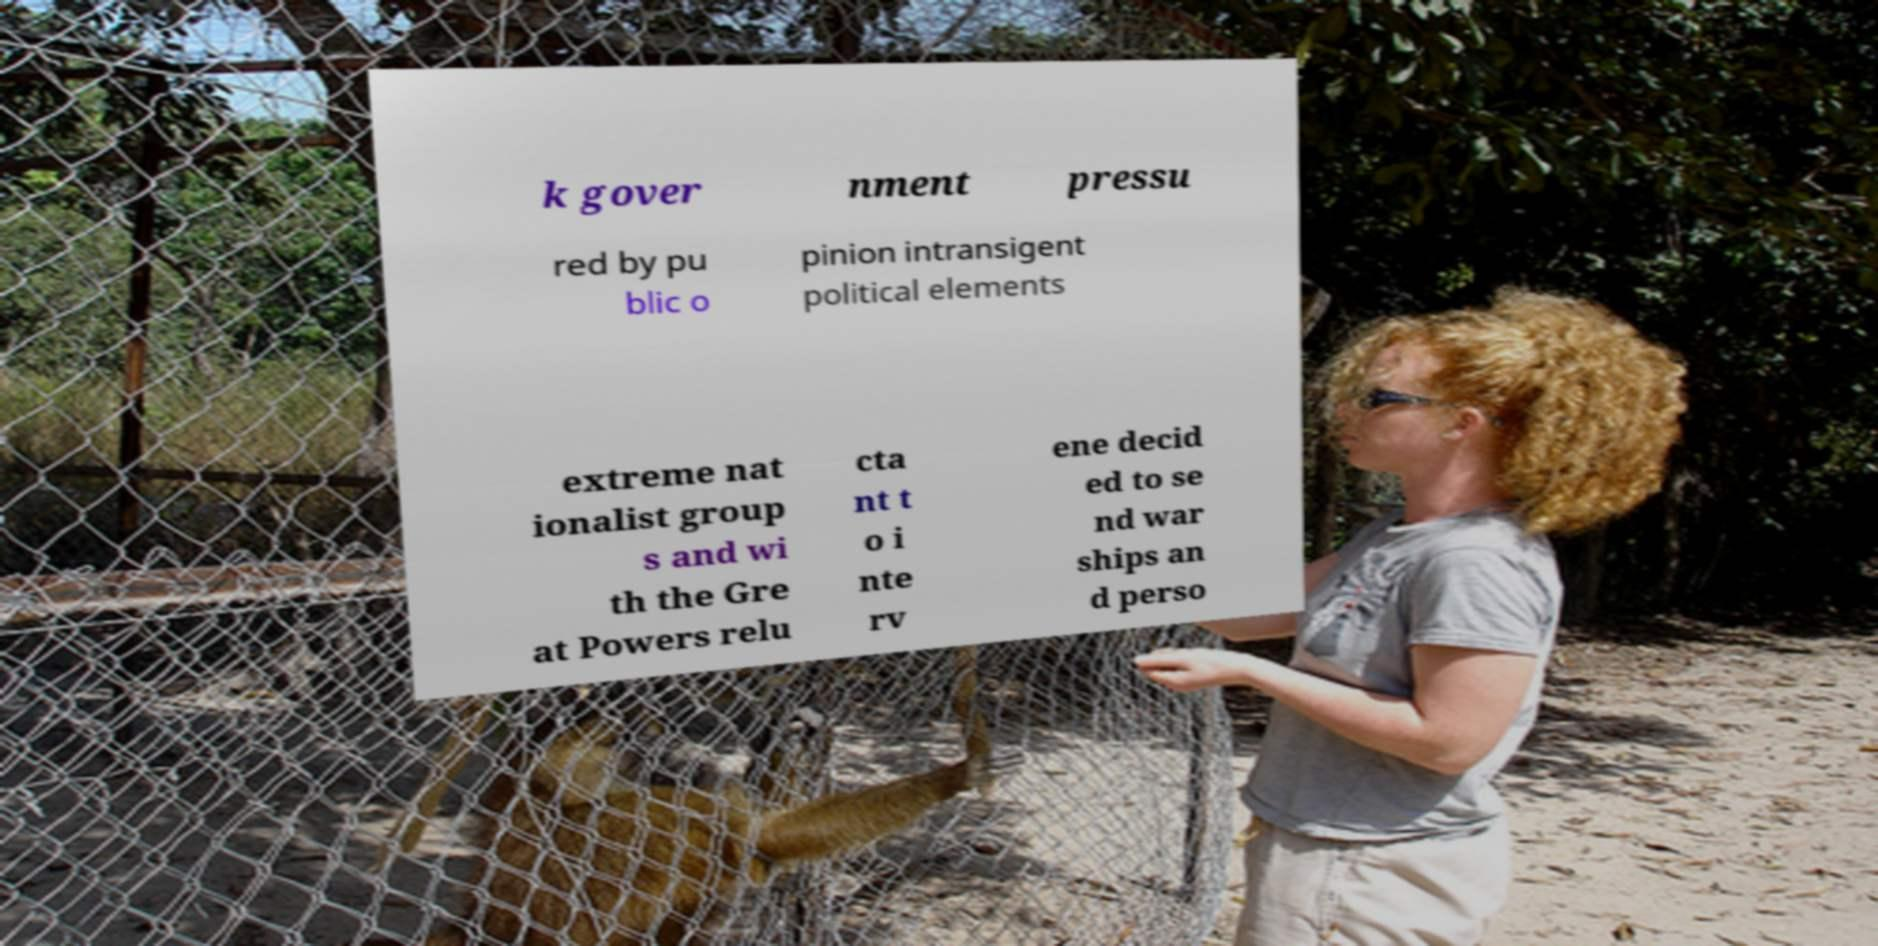Please read and relay the text visible in this image. What does it say? k gover nment pressu red by pu blic o pinion intransigent political elements extreme nat ionalist group s and wi th the Gre at Powers relu cta nt t o i nte rv ene decid ed to se nd war ships an d perso 